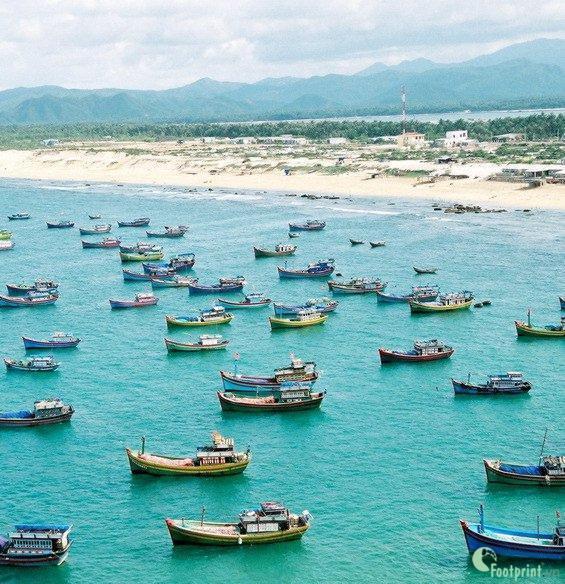How many boats are visible?
Give a very brief answer. 5. How many bananas are there?
Give a very brief answer. 0. 